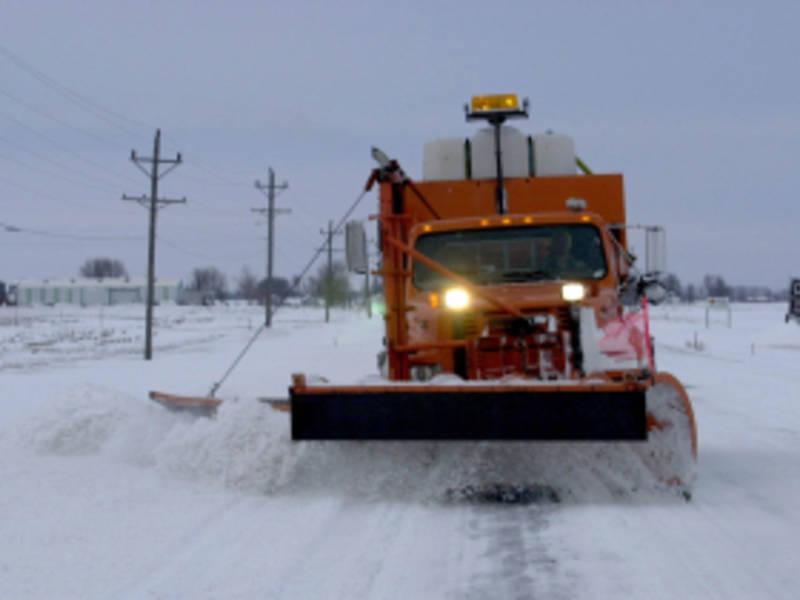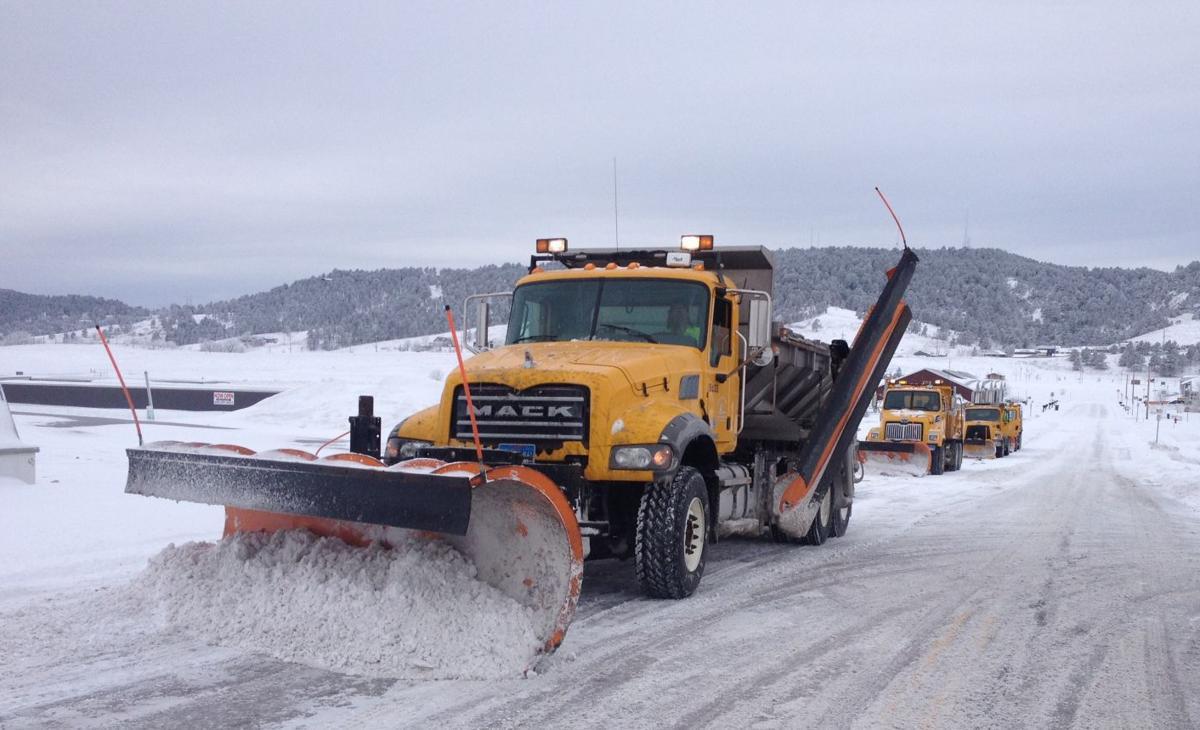The first image is the image on the left, the second image is the image on the right. Given the left and right images, does the statement "There is a line of plows in the right image and a single plow in the left." hold true? Answer yes or no. Yes. The first image is the image on the left, the second image is the image on the right. Analyze the images presented: Is the assertion "Both images show the front side of a snow plow." valid? Answer yes or no. Yes. 